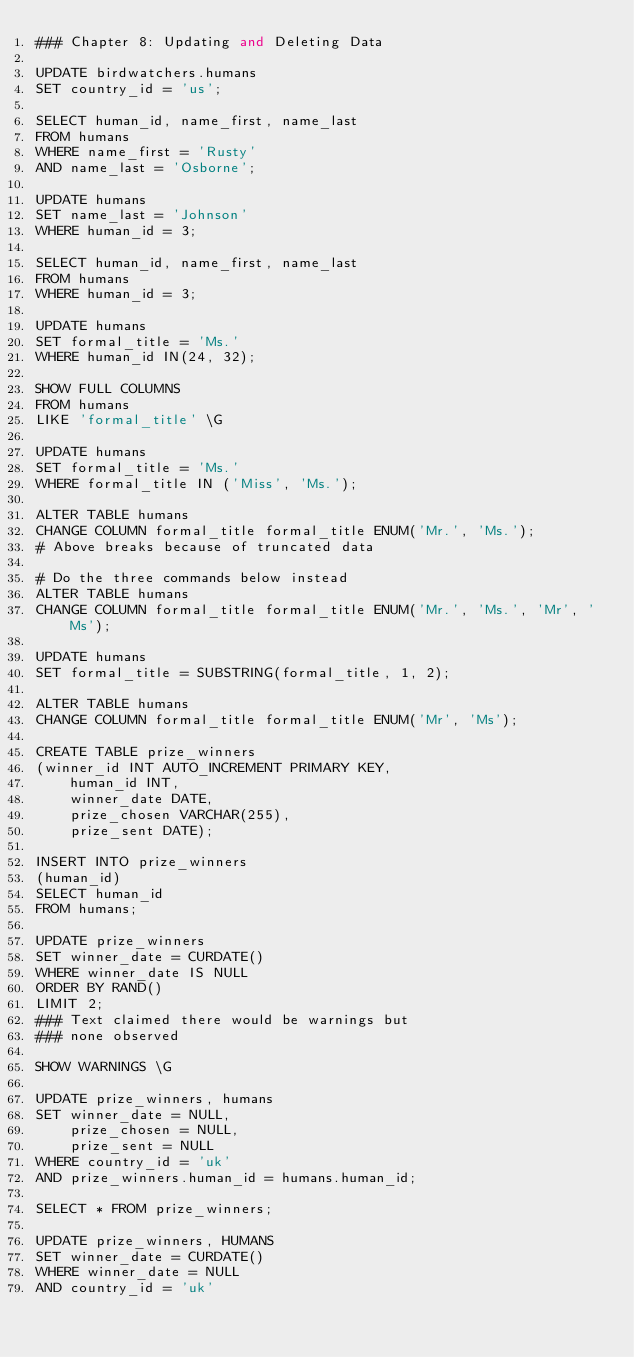Convert code to text. <code><loc_0><loc_0><loc_500><loc_500><_SQL_>### Chapter 8: Updating and Deleting Data

UPDATE birdwatchers.humans
SET country_id = 'us';

SELECT human_id, name_first, name_last
FROM humans
WHERE name_first = 'Rusty'
AND name_last = 'Osborne';

UPDATE humans
SET name_last = 'Johnson'
WHERE human_id = 3;

SELECT human_id, name_first, name_last
FROM humans
WHERE human_id = 3;

UPDATE humans
SET formal_title = 'Ms.'
WHERE human_id IN(24, 32);

SHOW FULL COLUMNS
FROM humans
LIKE 'formal_title' \G

UPDATE humans
SET formal_title = 'Ms.'
WHERE formal_title IN ('Miss', 'Ms.');

ALTER TABLE humans
CHANGE COLUMN formal_title formal_title ENUM('Mr.', 'Ms.');
# Above breaks because of truncated data

# Do the three commands below instead
ALTER TABLE humans
CHANGE COLUMN formal_title formal_title ENUM('Mr.', 'Ms.', 'Mr', 'Ms');

UPDATE humans
SET formal_title = SUBSTRING(formal_title, 1, 2);

ALTER TABLE humans
CHANGE COLUMN formal_title formal_title ENUM('Mr', 'Ms');

CREATE TABLE prize_winners
(winner_id INT AUTO_INCREMENT PRIMARY KEY,
    human_id INT,
    winner_date DATE,
    prize_chosen VARCHAR(255),
    prize_sent DATE);

INSERT INTO prize_winners
(human_id)
SELECT human_id
FROM humans;

UPDATE prize_winners
SET winner_date = CURDATE()
WHERE winner_date IS NULL
ORDER BY RAND()
LIMIT 2;
### Text claimed there would be warnings but
### none observed

SHOW WARNINGS \G

UPDATE prize_winners, humans
SET winner_date = NULL,
    prize_chosen = NULL,
    prize_sent = NULL
WHERE country_id = 'uk'
AND prize_winners.human_id = humans.human_id;

SELECT * FROM prize_winners;

UPDATE prize_winners, HUMANS
SET winner_date = CURDATE()
WHERE winner_date = NULL
AND country_id = 'uk'</code> 